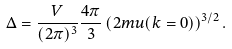<formula> <loc_0><loc_0><loc_500><loc_500>\Delta = \frac { V } { ( 2 \pi ) ^ { 3 } } \frac { 4 \pi } { 3 } \left ( 2 m u ( k = 0 ) \right ) ^ { 3 / 2 } .</formula> 